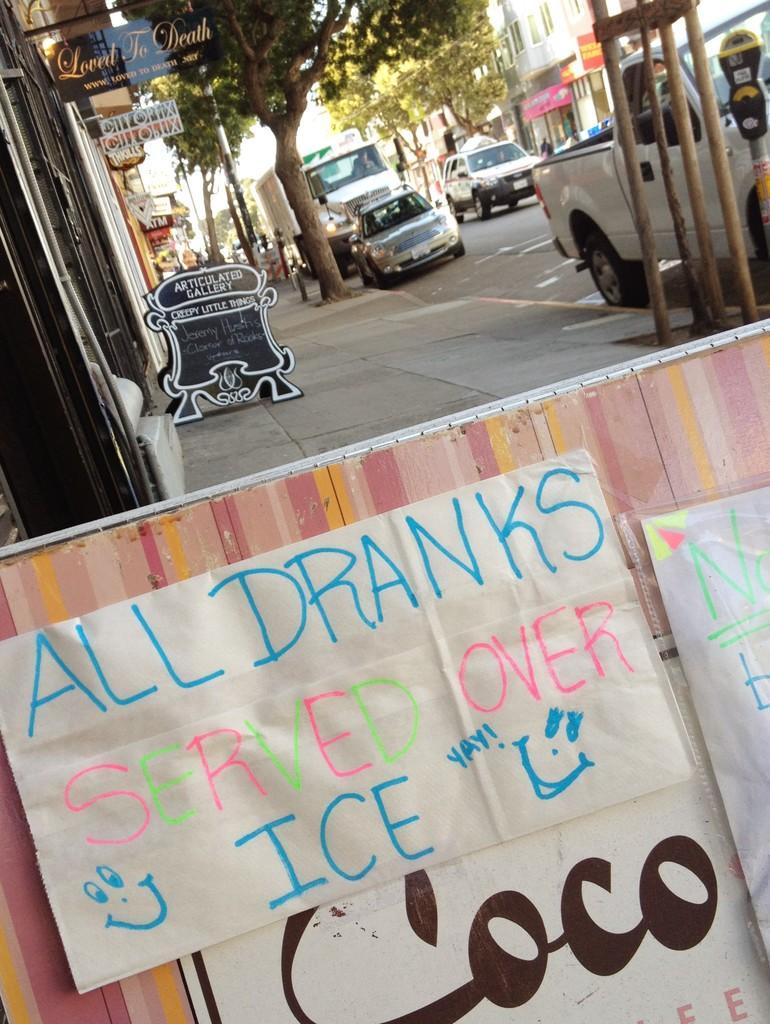Can you describe this image briefly? In this picture we can see small board in front bottom side. Behind we can see some shop door. On the right corner we can see some cars are parked on the roadside. Behind we can see trees. 